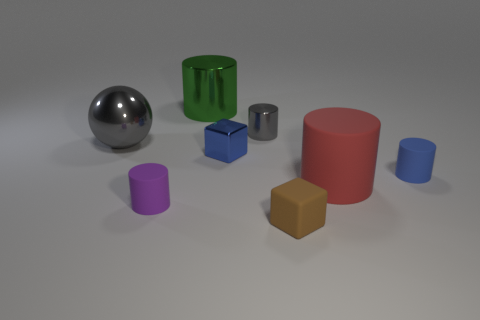Subtract all red cylinders. How many cylinders are left? 4 Subtract all large red rubber cylinders. How many cylinders are left? 4 Subtract all yellow cylinders. Subtract all purple spheres. How many cylinders are left? 5 Add 1 brown metal cylinders. How many objects exist? 9 Subtract all balls. How many objects are left? 7 Add 8 large green matte spheres. How many large green matte spheres exist? 8 Subtract 1 gray spheres. How many objects are left? 7 Subtract all tiny green metallic things. Subtract all large green metallic cylinders. How many objects are left? 7 Add 5 tiny brown rubber things. How many tiny brown rubber things are left? 6 